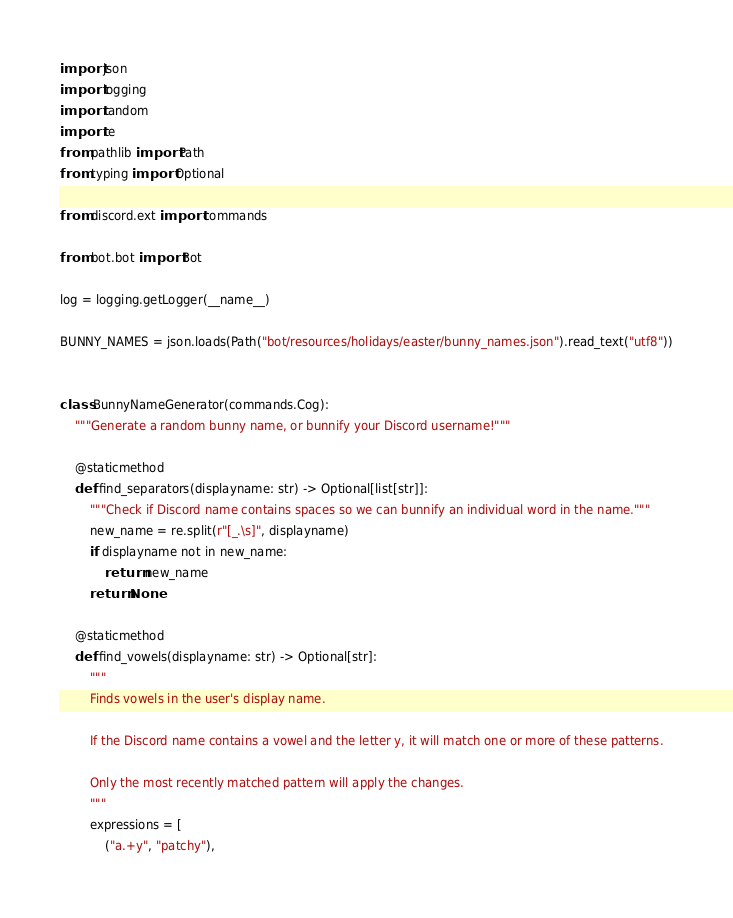<code> <loc_0><loc_0><loc_500><loc_500><_Python_>import json
import logging
import random
import re
from pathlib import Path
from typing import Optional

from discord.ext import commands

from bot.bot import Bot

log = logging.getLogger(__name__)

BUNNY_NAMES = json.loads(Path("bot/resources/holidays/easter/bunny_names.json").read_text("utf8"))


class BunnyNameGenerator(commands.Cog):
    """Generate a random bunny name, or bunnify your Discord username!"""

    @staticmethod
    def find_separators(displayname: str) -> Optional[list[str]]:
        """Check if Discord name contains spaces so we can bunnify an individual word in the name."""
        new_name = re.split(r"[_.\s]", displayname)
        if displayname not in new_name:
            return new_name
        return None

    @staticmethod
    def find_vowels(displayname: str) -> Optional[str]:
        """
        Finds vowels in the user's display name.

        If the Discord name contains a vowel and the letter y, it will match one or more of these patterns.

        Only the most recently matched pattern will apply the changes.
        """
        expressions = [
            ("a.+y", "patchy"),</code> 